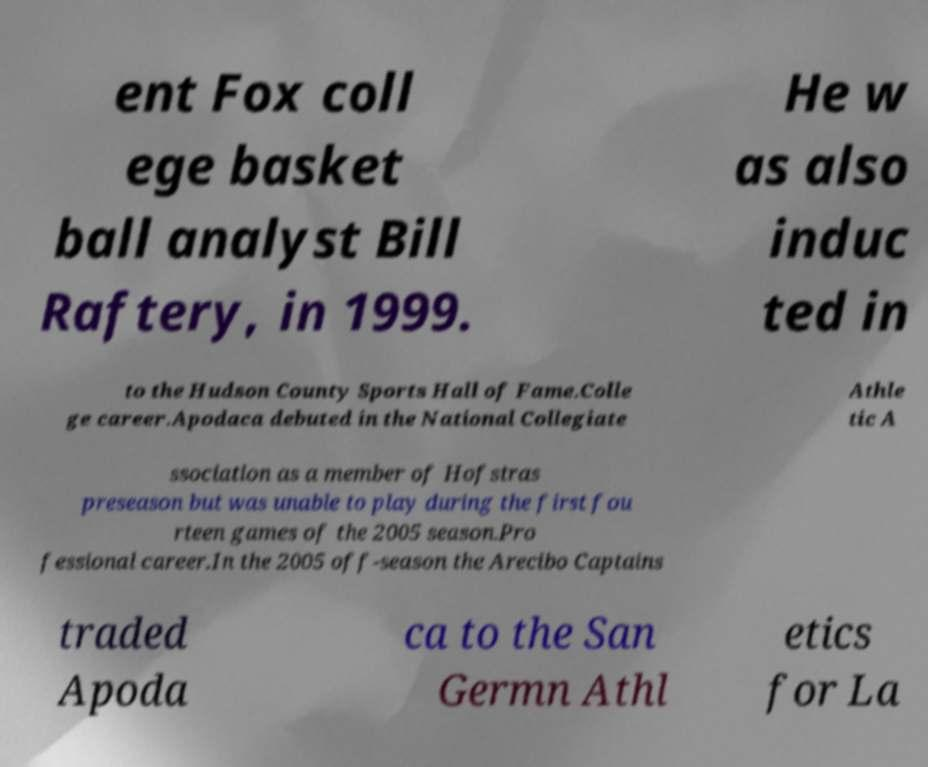There's text embedded in this image that I need extracted. Can you transcribe it verbatim? ent Fox coll ege basket ball analyst Bill Raftery, in 1999. He w as also induc ted in to the Hudson County Sports Hall of Fame.Colle ge career.Apodaca debuted in the National Collegiate Athle tic A ssociation as a member of Hofstras preseason but was unable to play during the first fou rteen games of the 2005 season.Pro fessional career.In the 2005 off-season the Arecibo Captains traded Apoda ca to the San Germn Athl etics for La 